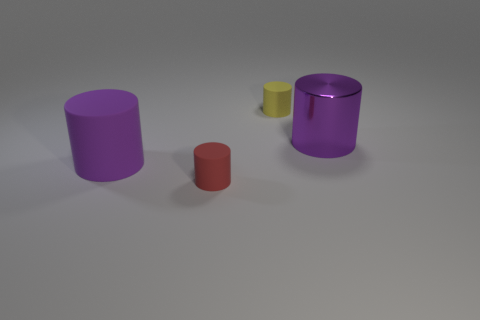The object that is in front of the yellow matte object and right of the red matte thing is what color?
Provide a succinct answer. Purple. What number of cylinders are small metallic objects or metal objects?
Provide a short and direct response. 1. How many yellow cylinders are the same size as the red rubber cylinder?
Make the answer very short. 1. There is a big purple cylinder on the left side of the metallic cylinder; how many big objects are behind it?
Your answer should be very brief. 1. There is a matte thing that is both behind the tiny red cylinder and in front of the yellow cylinder; what is its size?
Keep it short and to the point. Large. Are there more big purple rubber cylinders than big gray metallic cylinders?
Offer a terse response. Yes. Are there any large cylinders that have the same color as the large metal object?
Ensure brevity in your answer.  Yes. There is a object behind the shiny cylinder; is its size the same as the large purple metallic object?
Keep it short and to the point. No. Are there fewer tiny blue blocks than big purple rubber cylinders?
Your answer should be compact. Yes. Are there any small yellow objects made of the same material as the tiny yellow cylinder?
Your answer should be very brief. No. 